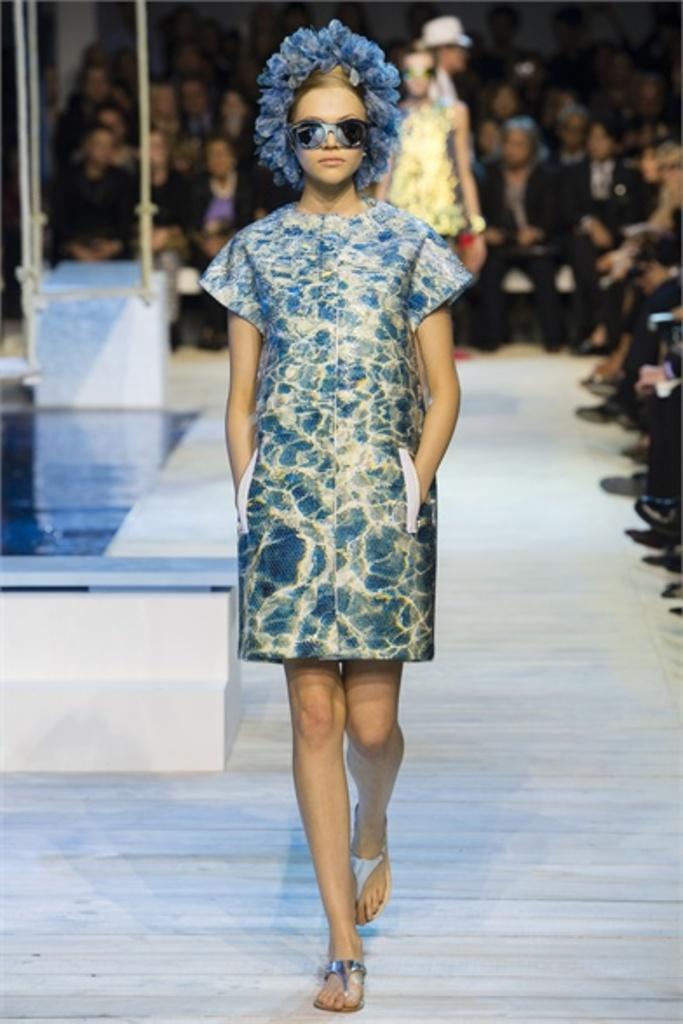Describe this image in one or two sentences. In this picture there is a woman who is doing ramp walk. In the back I can see another woman who is wearing yellow dress and she is also doing a ramp walk. Beside her I can see many people who are wearing the black suits and they are sitting on the chair. 